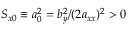<formula> <loc_0><loc_0><loc_500><loc_500>S _ { x 0 } \equiv a _ { 0 } ^ { 2 } = b _ { y } ^ { 2 } / ( 2 a _ { x x } ) ^ { 2 } > 0</formula> 